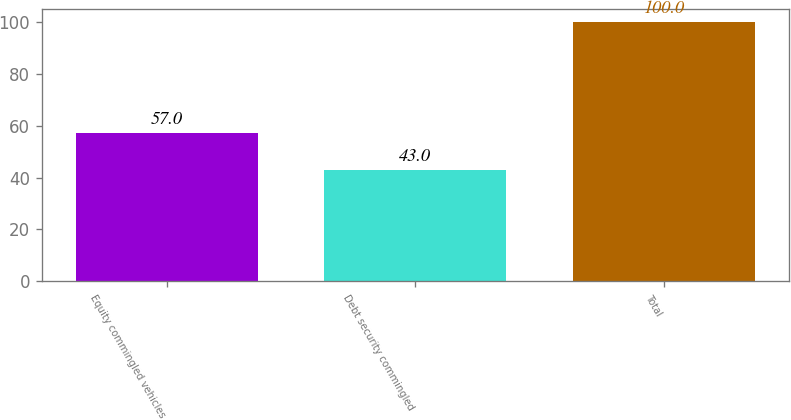<chart> <loc_0><loc_0><loc_500><loc_500><bar_chart><fcel>Equity commingled vehicles<fcel>Debt security commingled<fcel>Total<nl><fcel>57<fcel>43<fcel>100<nl></chart> 